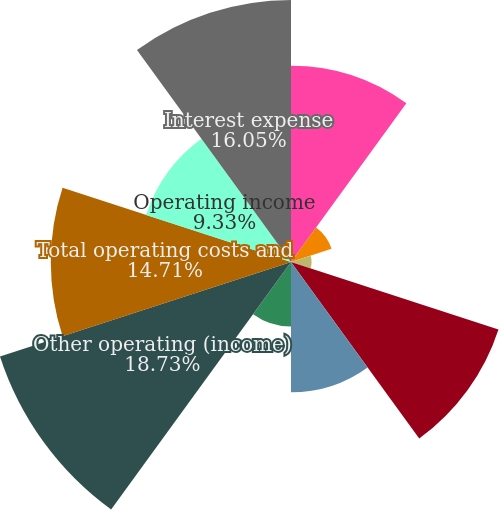<chart> <loc_0><loc_0><loc_500><loc_500><pie_chart><fcel>Sales by Company-operated<fcel>Revenues from franchised<fcel>Total revenues<fcel>Company-operated restaurant<fcel>Franchised<fcel>Selling general &<fcel>Other operating (income)<fcel>Total operating costs and<fcel>Operating income<fcel>Interest expense<nl><fcel>12.02%<fcel>2.61%<fcel>1.26%<fcel>13.36%<fcel>7.98%<fcel>3.95%<fcel>18.74%<fcel>14.71%<fcel>9.33%<fcel>16.05%<nl></chart> 